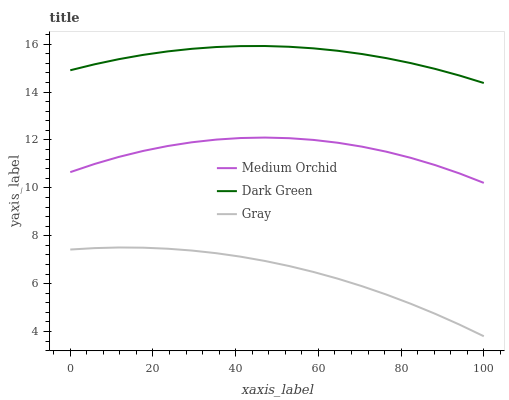Does Gray have the minimum area under the curve?
Answer yes or no. Yes. Does Dark Green have the maximum area under the curve?
Answer yes or no. Yes. Does Medium Orchid have the minimum area under the curve?
Answer yes or no. No. Does Medium Orchid have the maximum area under the curve?
Answer yes or no. No. Is Gray the smoothest?
Answer yes or no. Yes. Is Medium Orchid the roughest?
Answer yes or no. Yes. Is Dark Green the smoothest?
Answer yes or no. No. Is Dark Green the roughest?
Answer yes or no. No. Does Gray have the lowest value?
Answer yes or no. Yes. Does Medium Orchid have the lowest value?
Answer yes or no. No. Does Dark Green have the highest value?
Answer yes or no. Yes. Does Medium Orchid have the highest value?
Answer yes or no. No. Is Gray less than Medium Orchid?
Answer yes or no. Yes. Is Medium Orchid greater than Gray?
Answer yes or no. Yes. Does Gray intersect Medium Orchid?
Answer yes or no. No. 